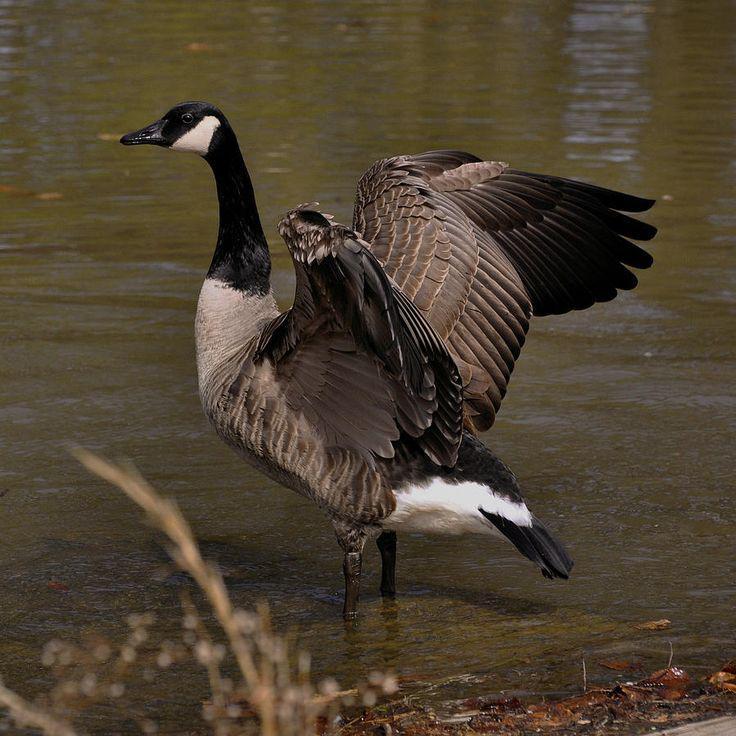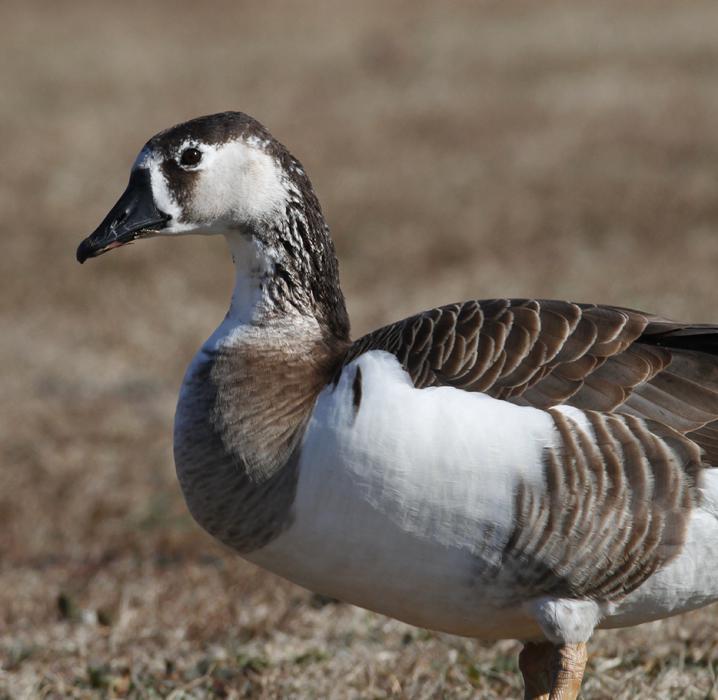The first image is the image on the left, the second image is the image on the right. Assess this claim about the two images: "All the ducks in the image are facing the same direction.". Correct or not? Answer yes or no. Yes. 